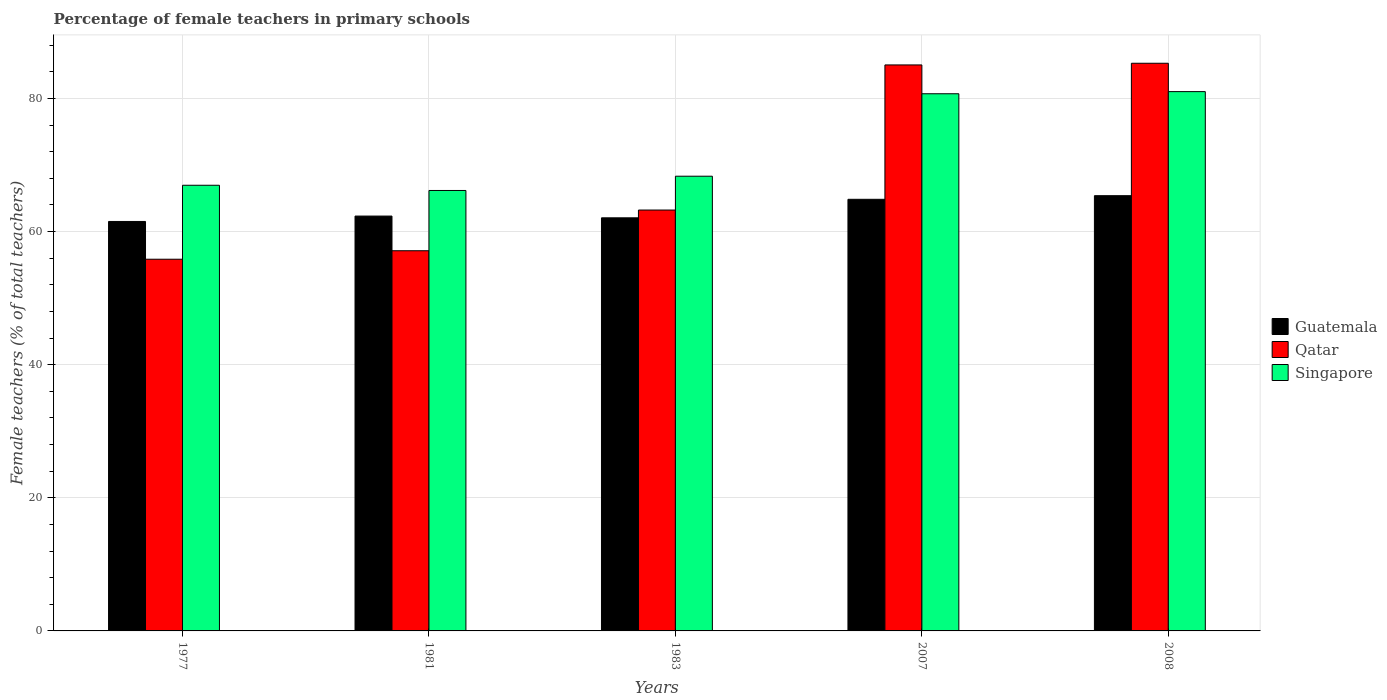How many groups of bars are there?
Keep it short and to the point. 5. Are the number of bars per tick equal to the number of legend labels?
Offer a terse response. Yes. How many bars are there on the 1st tick from the left?
Provide a short and direct response. 3. How many bars are there on the 3rd tick from the right?
Provide a short and direct response. 3. What is the label of the 1st group of bars from the left?
Ensure brevity in your answer.  1977. In how many cases, is the number of bars for a given year not equal to the number of legend labels?
Offer a terse response. 0. What is the percentage of female teachers in Singapore in 2007?
Provide a short and direct response. 80.71. Across all years, what is the maximum percentage of female teachers in Qatar?
Ensure brevity in your answer.  85.29. Across all years, what is the minimum percentage of female teachers in Guatemala?
Give a very brief answer. 61.52. In which year was the percentage of female teachers in Guatemala maximum?
Offer a terse response. 2008. What is the total percentage of female teachers in Qatar in the graph?
Provide a succinct answer. 346.54. What is the difference between the percentage of female teachers in Guatemala in 1977 and that in 1981?
Your response must be concise. -0.81. What is the difference between the percentage of female teachers in Singapore in 2008 and the percentage of female teachers in Guatemala in 1977?
Provide a succinct answer. 19.51. What is the average percentage of female teachers in Singapore per year?
Give a very brief answer. 72.64. In the year 2007, what is the difference between the percentage of female teachers in Singapore and percentage of female teachers in Qatar?
Give a very brief answer. -4.33. What is the ratio of the percentage of female teachers in Singapore in 1983 to that in 2007?
Your response must be concise. 0.85. Is the percentage of female teachers in Qatar in 1981 less than that in 1983?
Keep it short and to the point. Yes. What is the difference between the highest and the second highest percentage of female teachers in Qatar?
Make the answer very short. 0.25. What is the difference between the highest and the lowest percentage of female teachers in Guatemala?
Provide a succinct answer. 3.87. Is the sum of the percentage of female teachers in Singapore in 1981 and 1983 greater than the maximum percentage of female teachers in Qatar across all years?
Your answer should be compact. Yes. What does the 2nd bar from the left in 1981 represents?
Make the answer very short. Qatar. What does the 1st bar from the right in 2008 represents?
Provide a short and direct response. Singapore. Is it the case that in every year, the sum of the percentage of female teachers in Qatar and percentage of female teachers in Guatemala is greater than the percentage of female teachers in Singapore?
Your answer should be compact. Yes. How many bars are there?
Your answer should be very brief. 15. What is the difference between two consecutive major ticks on the Y-axis?
Give a very brief answer. 20. Are the values on the major ticks of Y-axis written in scientific E-notation?
Ensure brevity in your answer.  No. Does the graph contain any zero values?
Offer a very short reply. No. Where does the legend appear in the graph?
Your response must be concise. Center right. How are the legend labels stacked?
Give a very brief answer. Vertical. What is the title of the graph?
Your response must be concise. Percentage of female teachers in primary schools. Does "Mozambique" appear as one of the legend labels in the graph?
Your answer should be very brief. No. What is the label or title of the X-axis?
Your answer should be very brief. Years. What is the label or title of the Y-axis?
Give a very brief answer. Female teachers (% of total teachers). What is the Female teachers (% of total teachers) in Guatemala in 1977?
Offer a very short reply. 61.52. What is the Female teachers (% of total teachers) in Qatar in 1977?
Your answer should be compact. 55.85. What is the Female teachers (% of total teachers) in Singapore in 1977?
Offer a very short reply. 66.96. What is the Female teachers (% of total teachers) in Guatemala in 1981?
Offer a very short reply. 62.33. What is the Female teachers (% of total teachers) of Qatar in 1981?
Provide a short and direct response. 57.12. What is the Female teachers (% of total teachers) in Singapore in 1981?
Ensure brevity in your answer.  66.18. What is the Female teachers (% of total teachers) of Guatemala in 1983?
Give a very brief answer. 62.07. What is the Female teachers (% of total teachers) in Qatar in 1983?
Your answer should be compact. 63.24. What is the Female teachers (% of total teachers) in Singapore in 1983?
Provide a short and direct response. 68.32. What is the Female teachers (% of total teachers) of Guatemala in 2007?
Provide a short and direct response. 64.85. What is the Female teachers (% of total teachers) of Qatar in 2007?
Your answer should be compact. 85.04. What is the Female teachers (% of total teachers) in Singapore in 2007?
Ensure brevity in your answer.  80.71. What is the Female teachers (% of total teachers) in Guatemala in 2008?
Ensure brevity in your answer.  65.39. What is the Female teachers (% of total teachers) of Qatar in 2008?
Give a very brief answer. 85.29. What is the Female teachers (% of total teachers) in Singapore in 2008?
Provide a succinct answer. 81.03. Across all years, what is the maximum Female teachers (% of total teachers) of Guatemala?
Keep it short and to the point. 65.39. Across all years, what is the maximum Female teachers (% of total teachers) in Qatar?
Make the answer very short. 85.29. Across all years, what is the maximum Female teachers (% of total teachers) in Singapore?
Your answer should be compact. 81.03. Across all years, what is the minimum Female teachers (% of total teachers) of Guatemala?
Your answer should be very brief. 61.52. Across all years, what is the minimum Female teachers (% of total teachers) of Qatar?
Your answer should be very brief. 55.85. Across all years, what is the minimum Female teachers (% of total teachers) of Singapore?
Your answer should be very brief. 66.18. What is the total Female teachers (% of total teachers) in Guatemala in the graph?
Provide a short and direct response. 316.17. What is the total Female teachers (% of total teachers) of Qatar in the graph?
Provide a short and direct response. 346.54. What is the total Female teachers (% of total teachers) of Singapore in the graph?
Make the answer very short. 363.2. What is the difference between the Female teachers (% of total teachers) of Guatemala in 1977 and that in 1981?
Your answer should be very brief. -0.81. What is the difference between the Female teachers (% of total teachers) of Qatar in 1977 and that in 1981?
Give a very brief answer. -1.28. What is the difference between the Female teachers (% of total teachers) of Singapore in 1977 and that in 1981?
Give a very brief answer. 0.78. What is the difference between the Female teachers (% of total teachers) of Guatemala in 1977 and that in 1983?
Give a very brief answer. -0.55. What is the difference between the Female teachers (% of total teachers) of Qatar in 1977 and that in 1983?
Your answer should be compact. -7.39. What is the difference between the Female teachers (% of total teachers) in Singapore in 1977 and that in 1983?
Give a very brief answer. -1.36. What is the difference between the Female teachers (% of total teachers) in Guatemala in 1977 and that in 2007?
Give a very brief answer. -3.33. What is the difference between the Female teachers (% of total teachers) in Qatar in 1977 and that in 2007?
Your answer should be compact. -29.19. What is the difference between the Female teachers (% of total teachers) of Singapore in 1977 and that in 2007?
Your answer should be compact. -13.75. What is the difference between the Female teachers (% of total teachers) of Guatemala in 1977 and that in 2008?
Your answer should be compact. -3.87. What is the difference between the Female teachers (% of total teachers) of Qatar in 1977 and that in 2008?
Provide a succinct answer. -29.45. What is the difference between the Female teachers (% of total teachers) of Singapore in 1977 and that in 2008?
Ensure brevity in your answer.  -14.07. What is the difference between the Female teachers (% of total teachers) of Guatemala in 1981 and that in 1983?
Your answer should be very brief. 0.26. What is the difference between the Female teachers (% of total teachers) in Qatar in 1981 and that in 1983?
Your answer should be compact. -6.12. What is the difference between the Female teachers (% of total teachers) in Singapore in 1981 and that in 1983?
Offer a terse response. -2.14. What is the difference between the Female teachers (% of total teachers) of Guatemala in 1981 and that in 2007?
Ensure brevity in your answer.  -2.52. What is the difference between the Female teachers (% of total teachers) of Qatar in 1981 and that in 2007?
Offer a terse response. -27.92. What is the difference between the Female teachers (% of total teachers) in Singapore in 1981 and that in 2007?
Provide a short and direct response. -14.53. What is the difference between the Female teachers (% of total teachers) of Guatemala in 1981 and that in 2008?
Keep it short and to the point. -3.06. What is the difference between the Female teachers (% of total teachers) of Qatar in 1981 and that in 2008?
Keep it short and to the point. -28.17. What is the difference between the Female teachers (% of total teachers) in Singapore in 1981 and that in 2008?
Offer a very short reply. -14.85. What is the difference between the Female teachers (% of total teachers) of Guatemala in 1983 and that in 2007?
Your answer should be compact. -2.78. What is the difference between the Female teachers (% of total teachers) of Qatar in 1983 and that in 2007?
Offer a terse response. -21.8. What is the difference between the Female teachers (% of total teachers) of Singapore in 1983 and that in 2007?
Ensure brevity in your answer.  -12.39. What is the difference between the Female teachers (% of total teachers) of Guatemala in 1983 and that in 2008?
Ensure brevity in your answer.  -3.33. What is the difference between the Female teachers (% of total teachers) of Qatar in 1983 and that in 2008?
Offer a very short reply. -22.05. What is the difference between the Female teachers (% of total teachers) in Singapore in 1983 and that in 2008?
Provide a succinct answer. -12.71. What is the difference between the Female teachers (% of total teachers) in Guatemala in 2007 and that in 2008?
Make the answer very short. -0.54. What is the difference between the Female teachers (% of total teachers) of Qatar in 2007 and that in 2008?
Provide a short and direct response. -0.25. What is the difference between the Female teachers (% of total teachers) in Singapore in 2007 and that in 2008?
Make the answer very short. -0.32. What is the difference between the Female teachers (% of total teachers) of Guatemala in 1977 and the Female teachers (% of total teachers) of Qatar in 1981?
Your answer should be compact. 4.4. What is the difference between the Female teachers (% of total teachers) in Guatemala in 1977 and the Female teachers (% of total teachers) in Singapore in 1981?
Provide a short and direct response. -4.65. What is the difference between the Female teachers (% of total teachers) in Qatar in 1977 and the Female teachers (% of total teachers) in Singapore in 1981?
Keep it short and to the point. -10.33. What is the difference between the Female teachers (% of total teachers) in Guatemala in 1977 and the Female teachers (% of total teachers) in Qatar in 1983?
Provide a succinct answer. -1.72. What is the difference between the Female teachers (% of total teachers) in Guatemala in 1977 and the Female teachers (% of total teachers) in Singapore in 1983?
Offer a very short reply. -6.8. What is the difference between the Female teachers (% of total teachers) of Qatar in 1977 and the Female teachers (% of total teachers) of Singapore in 1983?
Provide a succinct answer. -12.47. What is the difference between the Female teachers (% of total teachers) of Guatemala in 1977 and the Female teachers (% of total teachers) of Qatar in 2007?
Your answer should be very brief. -23.52. What is the difference between the Female teachers (% of total teachers) of Guatemala in 1977 and the Female teachers (% of total teachers) of Singapore in 2007?
Your response must be concise. -19.19. What is the difference between the Female teachers (% of total teachers) of Qatar in 1977 and the Female teachers (% of total teachers) of Singapore in 2007?
Provide a succinct answer. -24.86. What is the difference between the Female teachers (% of total teachers) in Guatemala in 1977 and the Female teachers (% of total teachers) in Qatar in 2008?
Offer a terse response. -23.77. What is the difference between the Female teachers (% of total teachers) of Guatemala in 1977 and the Female teachers (% of total teachers) of Singapore in 2008?
Ensure brevity in your answer.  -19.51. What is the difference between the Female teachers (% of total teachers) of Qatar in 1977 and the Female teachers (% of total teachers) of Singapore in 2008?
Offer a terse response. -25.18. What is the difference between the Female teachers (% of total teachers) of Guatemala in 1981 and the Female teachers (% of total teachers) of Qatar in 1983?
Provide a succinct answer. -0.91. What is the difference between the Female teachers (% of total teachers) of Guatemala in 1981 and the Female teachers (% of total teachers) of Singapore in 1983?
Offer a terse response. -5.99. What is the difference between the Female teachers (% of total teachers) in Qatar in 1981 and the Female teachers (% of total teachers) in Singapore in 1983?
Provide a succinct answer. -11.2. What is the difference between the Female teachers (% of total teachers) in Guatemala in 1981 and the Female teachers (% of total teachers) in Qatar in 2007?
Your answer should be very brief. -22.71. What is the difference between the Female teachers (% of total teachers) of Guatemala in 1981 and the Female teachers (% of total teachers) of Singapore in 2007?
Your response must be concise. -18.38. What is the difference between the Female teachers (% of total teachers) of Qatar in 1981 and the Female teachers (% of total teachers) of Singapore in 2007?
Your answer should be very brief. -23.59. What is the difference between the Female teachers (% of total teachers) in Guatemala in 1981 and the Female teachers (% of total teachers) in Qatar in 2008?
Your response must be concise. -22.96. What is the difference between the Female teachers (% of total teachers) of Guatemala in 1981 and the Female teachers (% of total teachers) of Singapore in 2008?
Your answer should be very brief. -18.7. What is the difference between the Female teachers (% of total teachers) of Qatar in 1981 and the Female teachers (% of total teachers) of Singapore in 2008?
Offer a terse response. -23.91. What is the difference between the Female teachers (% of total teachers) in Guatemala in 1983 and the Female teachers (% of total teachers) in Qatar in 2007?
Ensure brevity in your answer.  -22.97. What is the difference between the Female teachers (% of total teachers) of Guatemala in 1983 and the Female teachers (% of total teachers) of Singapore in 2007?
Give a very brief answer. -18.64. What is the difference between the Female teachers (% of total teachers) in Qatar in 1983 and the Female teachers (% of total teachers) in Singapore in 2007?
Offer a very short reply. -17.47. What is the difference between the Female teachers (% of total teachers) in Guatemala in 1983 and the Female teachers (% of total teachers) in Qatar in 2008?
Your answer should be very brief. -23.22. What is the difference between the Female teachers (% of total teachers) of Guatemala in 1983 and the Female teachers (% of total teachers) of Singapore in 2008?
Your answer should be compact. -18.96. What is the difference between the Female teachers (% of total teachers) of Qatar in 1983 and the Female teachers (% of total teachers) of Singapore in 2008?
Offer a very short reply. -17.79. What is the difference between the Female teachers (% of total teachers) of Guatemala in 2007 and the Female teachers (% of total teachers) of Qatar in 2008?
Give a very brief answer. -20.44. What is the difference between the Female teachers (% of total teachers) in Guatemala in 2007 and the Female teachers (% of total teachers) in Singapore in 2008?
Offer a terse response. -16.18. What is the difference between the Female teachers (% of total teachers) in Qatar in 2007 and the Female teachers (% of total teachers) in Singapore in 2008?
Your answer should be compact. 4.01. What is the average Female teachers (% of total teachers) of Guatemala per year?
Offer a very short reply. 63.23. What is the average Female teachers (% of total teachers) in Qatar per year?
Your answer should be compact. 69.31. What is the average Female teachers (% of total teachers) of Singapore per year?
Your response must be concise. 72.64. In the year 1977, what is the difference between the Female teachers (% of total teachers) of Guatemala and Female teachers (% of total teachers) of Qatar?
Ensure brevity in your answer.  5.68. In the year 1977, what is the difference between the Female teachers (% of total teachers) of Guatemala and Female teachers (% of total teachers) of Singapore?
Make the answer very short. -5.44. In the year 1977, what is the difference between the Female teachers (% of total teachers) in Qatar and Female teachers (% of total teachers) in Singapore?
Your answer should be very brief. -11.11. In the year 1981, what is the difference between the Female teachers (% of total teachers) in Guatemala and Female teachers (% of total teachers) in Qatar?
Provide a short and direct response. 5.21. In the year 1981, what is the difference between the Female teachers (% of total teachers) of Guatemala and Female teachers (% of total teachers) of Singapore?
Keep it short and to the point. -3.85. In the year 1981, what is the difference between the Female teachers (% of total teachers) in Qatar and Female teachers (% of total teachers) in Singapore?
Offer a very short reply. -9.05. In the year 1983, what is the difference between the Female teachers (% of total teachers) of Guatemala and Female teachers (% of total teachers) of Qatar?
Ensure brevity in your answer.  -1.17. In the year 1983, what is the difference between the Female teachers (% of total teachers) in Guatemala and Female teachers (% of total teachers) in Singapore?
Provide a short and direct response. -6.25. In the year 1983, what is the difference between the Female teachers (% of total teachers) of Qatar and Female teachers (% of total teachers) of Singapore?
Offer a terse response. -5.08. In the year 2007, what is the difference between the Female teachers (% of total teachers) of Guatemala and Female teachers (% of total teachers) of Qatar?
Make the answer very short. -20.19. In the year 2007, what is the difference between the Female teachers (% of total teachers) in Guatemala and Female teachers (% of total teachers) in Singapore?
Offer a very short reply. -15.86. In the year 2007, what is the difference between the Female teachers (% of total teachers) of Qatar and Female teachers (% of total teachers) of Singapore?
Give a very brief answer. 4.33. In the year 2008, what is the difference between the Female teachers (% of total teachers) of Guatemala and Female teachers (% of total teachers) of Qatar?
Give a very brief answer. -19.9. In the year 2008, what is the difference between the Female teachers (% of total teachers) of Guatemala and Female teachers (% of total teachers) of Singapore?
Your answer should be compact. -15.64. In the year 2008, what is the difference between the Female teachers (% of total teachers) in Qatar and Female teachers (% of total teachers) in Singapore?
Your response must be concise. 4.26. What is the ratio of the Female teachers (% of total teachers) of Qatar in 1977 to that in 1981?
Ensure brevity in your answer.  0.98. What is the ratio of the Female teachers (% of total teachers) of Singapore in 1977 to that in 1981?
Make the answer very short. 1.01. What is the ratio of the Female teachers (% of total teachers) of Qatar in 1977 to that in 1983?
Your answer should be compact. 0.88. What is the ratio of the Female teachers (% of total teachers) of Singapore in 1977 to that in 1983?
Your answer should be very brief. 0.98. What is the ratio of the Female teachers (% of total teachers) in Guatemala in 1977 to that in 2007?
Give a very brief answer. 0.95. What is the ratio of the Female teachers (% of total teachers) in Qatar in 1977 to that in 2007?
Offer a very short reply. 0.66. What is the ratio of the Female teachers (% of total teachers) in Singapore in 1977 to that in 2007?
Your answer should be very brief. 0.83. What is the ratio of the Female teachers (% of total teachers) in Guatemala in 1977 to that in 2008?
Keep it short and to the point. 0.94. What is the ratio of the Female teachers (% of total teachers) in Qatar in 1977 to that in 2008?
Give a very brief answer. 0.65. What is the ratio of the Female teachers (% of total teachers) in Singapore in 1977 to that in 2008?
Ensure brevity in your answer.  0.83. What is the ratio of the Female teachers (% of total teachers) of Qatar in 1981 to that in 1983?
Offer a very short reply. 0.9. What is the ratio of the Female teachers (% of total teachers) in Singapore in 1981 to that in 1983?
Provide a short and direct response. 0.97. What is the ratio of the Female teachers (% of total teachers) in Guatemala in 1981 to that in 2007?
Provide a short and direct response. 0.96. What is the ratio of the Female teachers (% of total teachers) of Qatar in 1981 to that in 2007?
Offer a very short reply. 0.67. What is the ratio of the Female teachers (% of total teachers) in Singapore in 1981 to that in 2007?
Offer a terse response. 0.82. What is the ratio of the Female teachers (% of total teachers) in Guatemala in 1981 to that in 2008?
Ensure brevity in your answer.  0.95. What is the ratio of the Female teachers (% of total teachers) of Qatar in 1981 to that in 2008?
Keep it short and to the point. 0.67. What is the ratio of the Female teachers (% of total teachers) of Singapore in 1981 to that in 2008?
Make the answer very short. 0.82. What is the ratio of the Female teachers (% of total teachers) in Guatemala in 1983 to that in 2007?
Offer a very short reply. 0.96. What is the ratio of the Female teachers (% of total teachers) in Qatar in 1983 to that in 2007?
Your response must be concise. 0.74. What is the ratio of the Female teachers (% of total teachers) in Singapore in 1983 to that in 2007?
Your answer should be compact. 0.85. What is the ratio of the Female teachers (% of total teachers) of Guatemala in 1983 to that in 2008?
Your response must be concise. 0.95. What is the ratio of the Female teachers (% of total teachers) in Qatar in 1983 to that in 2008?
Your response must be concise. 0.74. What is the ratio of the Female teachers (% of total teachers) of Singapore in 1983 to that in 2008?
Offer a terse response. 0.84. What is the ratio of the Female teachers (% of total teachers) in Guatemala in 2007 to that in 2008?
Offer a very short reply. 0.99. What is the ratio of the Female teachers (% of total teachers) in Qatar in 2007 to that in 2008?
Provide a succinct answer. 1. What is the difference between the highest and the second highest Female teachers (% of total teachers) of Guatemala?
Your answer should be very brief. 0.54. What is the difference between the highest and the second highest Female teachers (% of total teachers) in Qatar?
Provide a short and direct response. 0.25. What is the difference between the highest and the second highest Female teachers (% of total teachers) of Singapore?
Offer a very short reply. 0.32. What is the difference between the highest and the lowest Female teachers (% of total teachers) in Guatemala?
Offer a terse response. 3.87. What is the difference between the highest and the lowest Female teachers (% of total teachers) of Qatar?
Your answer should be compact. 29.45. What is the difference between the highest and the lowest Female teachers (% of total teachers) in Singapore?
Provide a succinct answer. 14.85. 